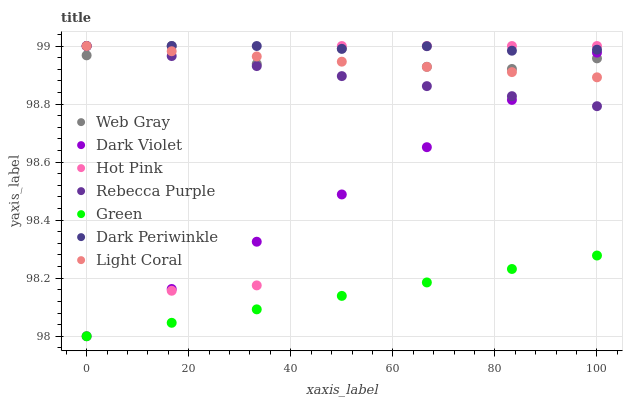Does Green have the minimum area under the curve?
Answer yes or no. Yes. Does Dark Periwinkle have the maximum area under the curve?
Answer yes or no. Yes. Does Hot Pink have the minimum area under the curve?
Answer yes or no. No. Does Hot Pink have the maximum area under the curve?
Answer yes or no. No. Is Green the smoothest?
Answer yes or no. Yes. Is Hot Pink the roughest?
Answer yes or no. Yes. Is Dark Violet the smoothest?
Answer yes or no. No. Is Dark Violet the roughest?
Answer yes or no. No. Does Dark Violet have the lowest value?
Answer yes or no. Yes. Does Hot Pink have the lowest value?
Answer yes or no. No. Does Dark Periwinkle have the highest value?
Answer yes or no. Yes. Does Dark Violet have the highest value?
Answer yes or no. No. Is Dark Violet less than Dark Periwinkle?
Answer yes or no. Yes. Is Dark Periwinkle greater than Green?
Answer yes or no. Yes. Does Dark Periwinkle intersect Hot Pink?
Answer yes or no. Yes. Is Dark Periwinkle less than Hot Pink?
Answer yes or no. No. Is Dark Periwinkle greater than Hot Pink?
Answer yes or no. No. Does Dark Violet intersect Dark Periwinkle?
Answer yes or no. No. 